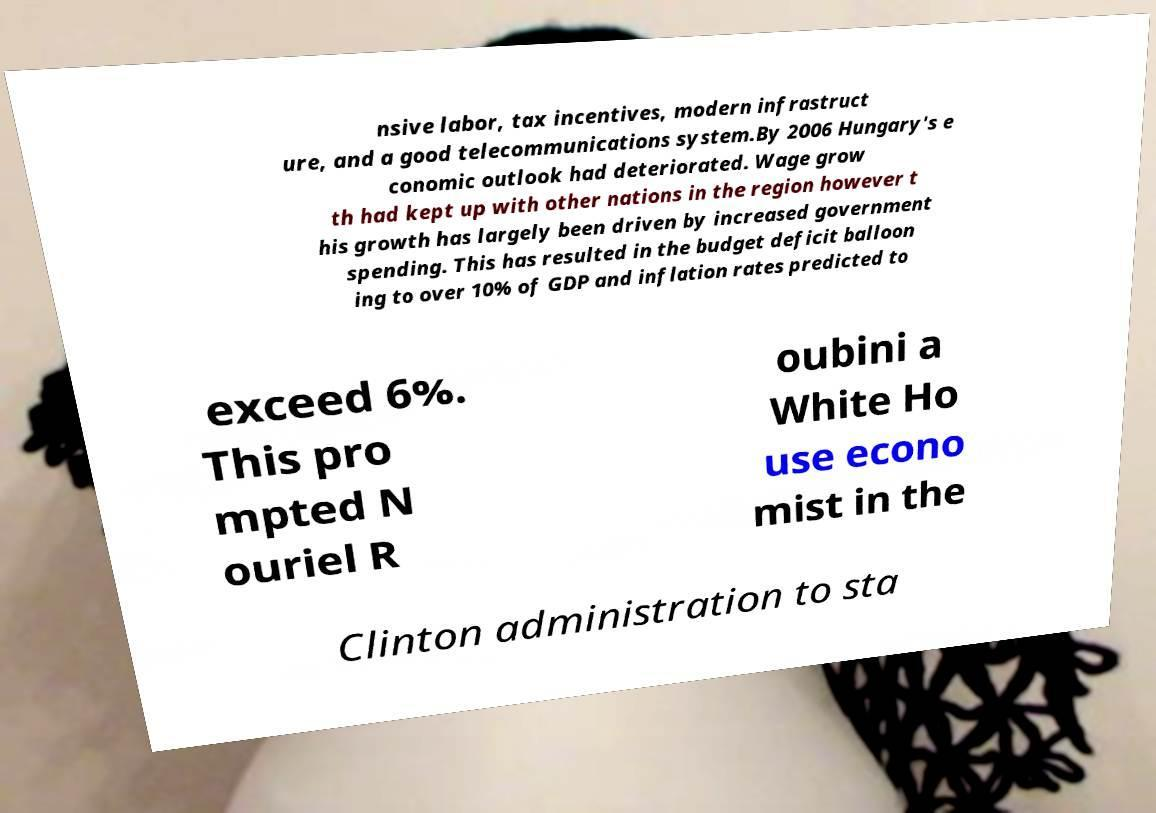There's text embedded in this image that I need extracted. Can you transcribe it verbatim? nsive labor, tax incentives, modern infrastruct ure, and a good telecommunications system.By 2006 Hungary's e conomic outlook had deteriorated. Wage grow th had kept up with other nations in the region however t his growth has largely been driven by increased government spending. This has resulted in the budget deficit balloon ing to over 10% of GDP and inflation rates predicted to exceed 6%. This pro mpted N ouriel R oubini a White Ho use econo mist in the Clinton administration to sta 